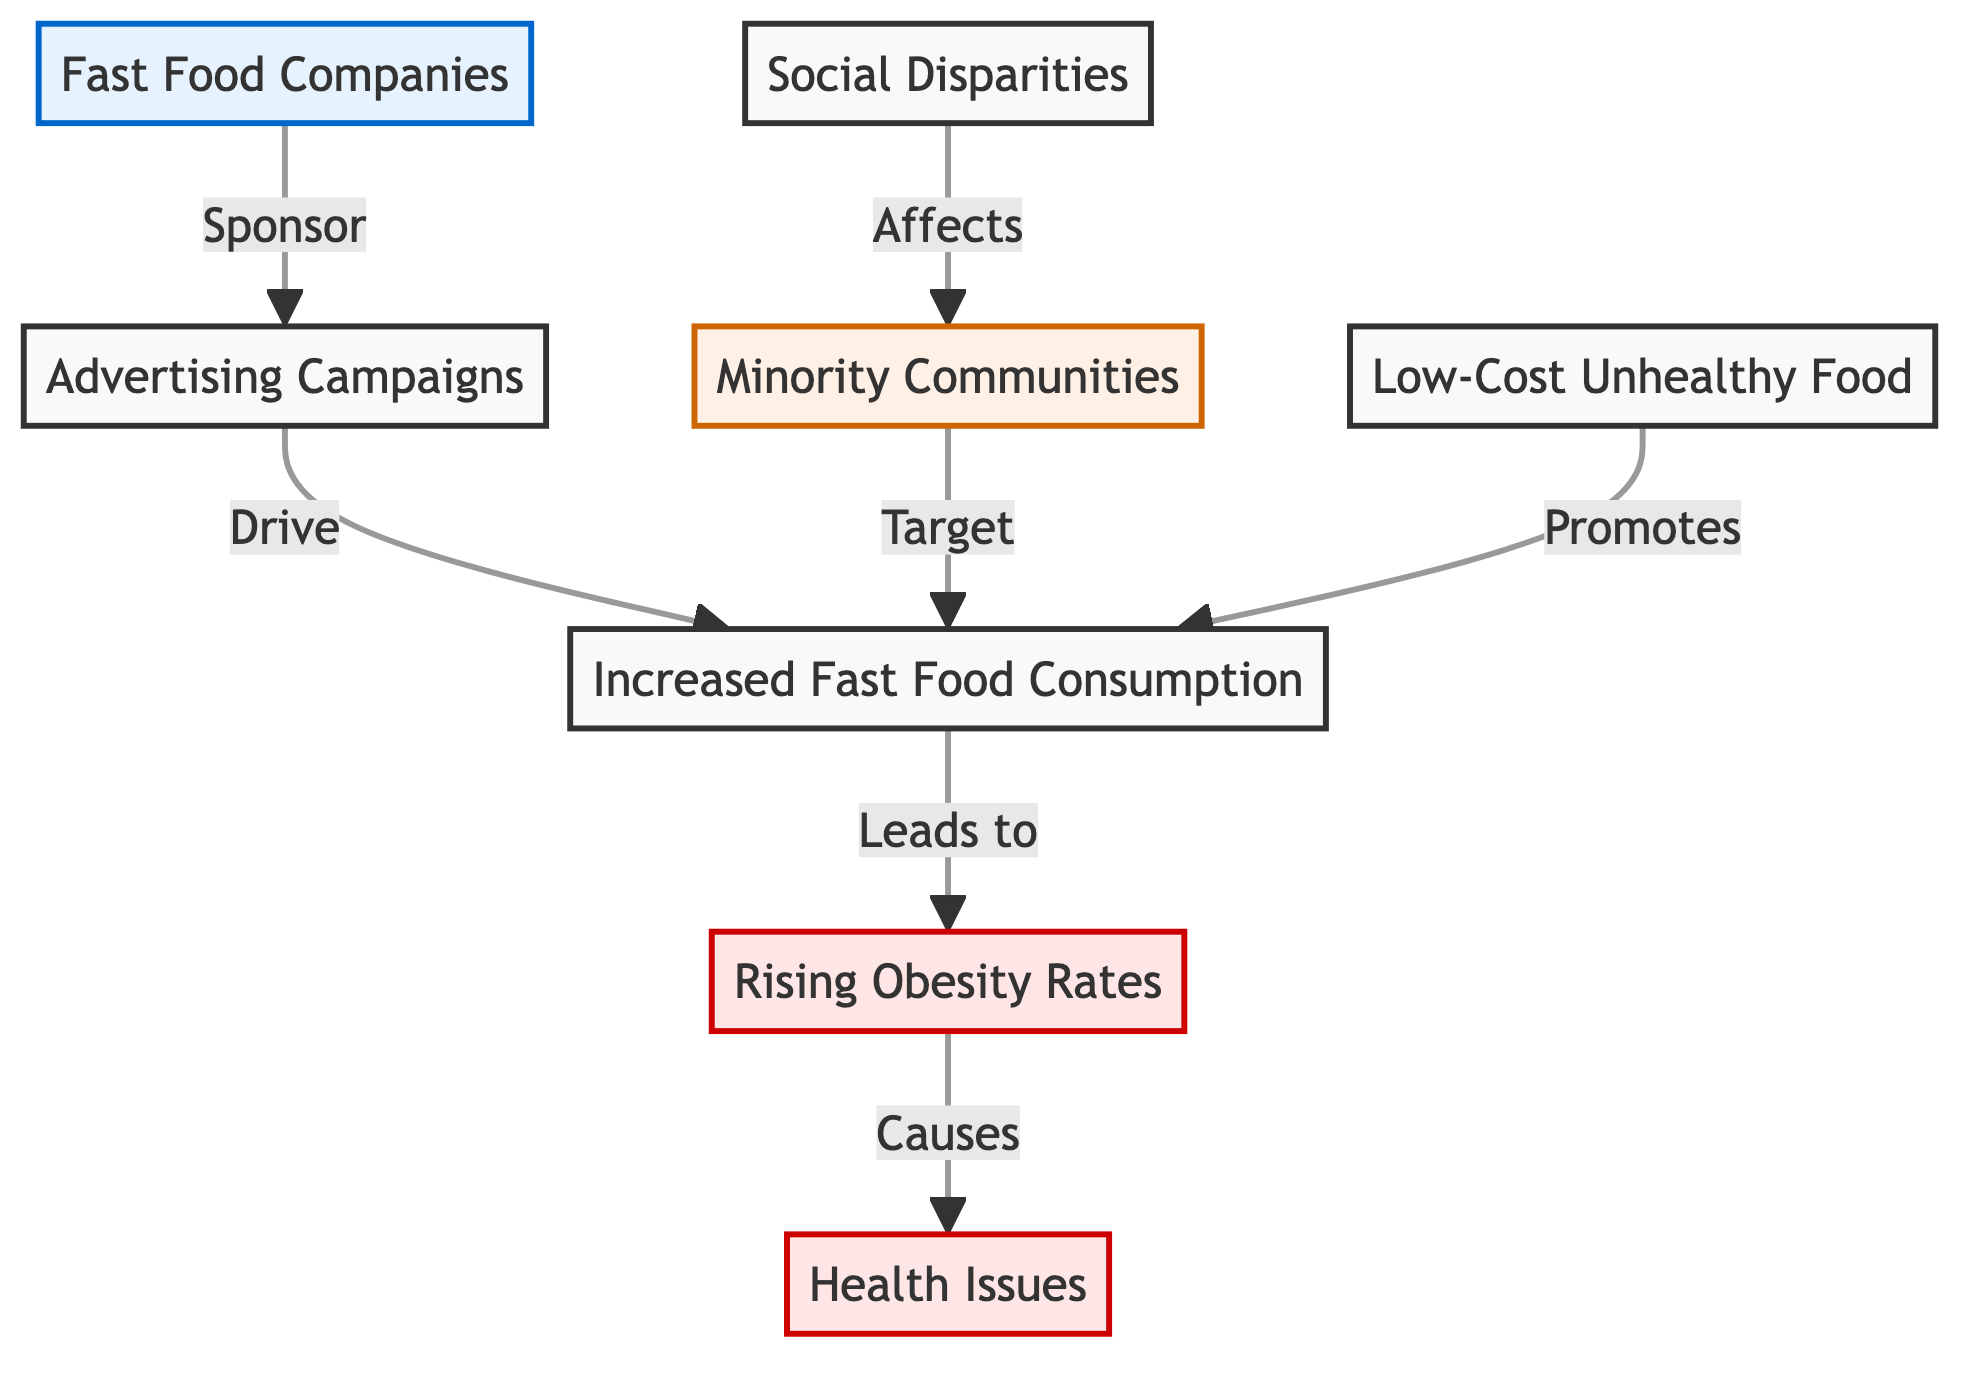What are the main elements represented in the diagram? The main elements represented include Fast Food Companies, Advertising Campaigns, Increased Fast Food Consumption, Minority Communities, Low-Cost Unhealthy Food, Social Disparities, Rising Obesity Rates, and Health Issues.
Answer: Fast Food Companies, Advertising Campaigns, Increased Fast Food Consumption, Minority Communities, Low-Cost Unhealthy Food, Social Disparities, Rising Obesity Rates, Health Issues How many nodes are displayed in the diagram? There are eight distinct nodes shown in the diagram: Fast Food Companies, Advertising Campaigns, Increased Fast Food Consumption, Minority Communities, Low-Cost Unhealthy Food, Social Disparities, Rising Obesity Rates, and Health Issues.
Answer: Eight What relationship exists between Fast Food Companies and Advertising Campaigns? Fast Food Companies sponsor Advertising Campaigns, indicating a direct financial or promotional relationship that aims to advertise their products.
Answer: Sponsor Which community is specifically targeted by the advertising efforts in the diagram? The diagram indicates that Minority Communities are specifically targeted for increased fast food consumption through advertising campaigns.
Answer: Minority Communities What effect does Increased Fast Food Consumption have on health outcomes? According to the diagram, Increased Fast Food Consumption leads to Rising Obesity Rates, which in turn causes Health Issues, establishing a link between diet and health outcomes.
Answer: Leads to Explain the interaction between Social Disparities and Minority Communities. The diagram shows that Social Disparities affect Minority Communities, implying that the socio-economic conditions contribute to their vulnerability to fast food marketing and resultant health risks.
Answer: Affects What common factor promotes Increased Fast Food Consumption? The diagram illustrates that Low-Cost Unhealthy Food promotes Increased Fast Food Consumption, highlighting economic factors that make fast food more accessible to certain communities.
Answer: Promotes How does the diagram visually represent the flow of causality? The diagram uses directed arrows to indicate the flow between nodes, showing how one factor leads to another, such as how Advertising Campaigns drive Increased Fast Food Consumption, which leads to Rising Obesity Rates.
Answer: Directed arrows What is the final health outcome linked to Rising Obesity Rates in the diagram? Health Issues are shown as the final outcome linked to Rising Obesity Rates, which establishes a connection between obesity as a consequence of fast food consumption and broader health challenges.
Answer: Health Issues 